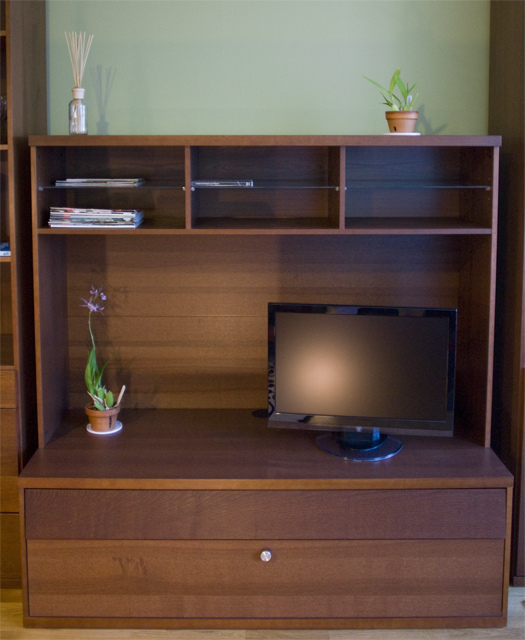<image>Where is the modem? It is unknown where the modem is located. It could be on the right side of the desk, on a shelf, or even off camera. Where is the modem? I don't know where the modem is. 